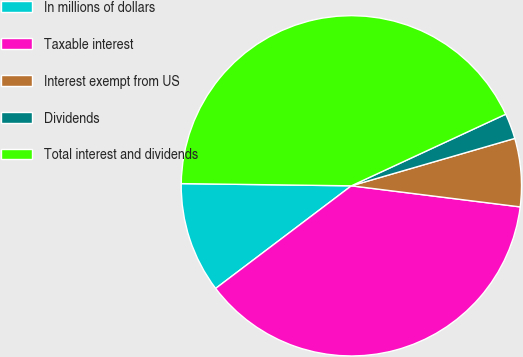Convert chart to OTSL. <chart><loc_0><loc_0><loc_500><loc_500><pie_chart><fcel>In millions of dollars<fcel>Taxable interest<fcel>Interest exempt from US<fcel>Dividends<fcel>Total interest and dividends<nl><fcel>10.51%<fcel>37.72%<fcel>6.47%<fcel>2.42%<fcel>42.88%<nl></chart> 